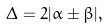Convert formula to latex. <formula><loc_0><loc_0><loc_500><loc_500>\Delta = 2 | \alpha \pm \beta | ,</formula> 